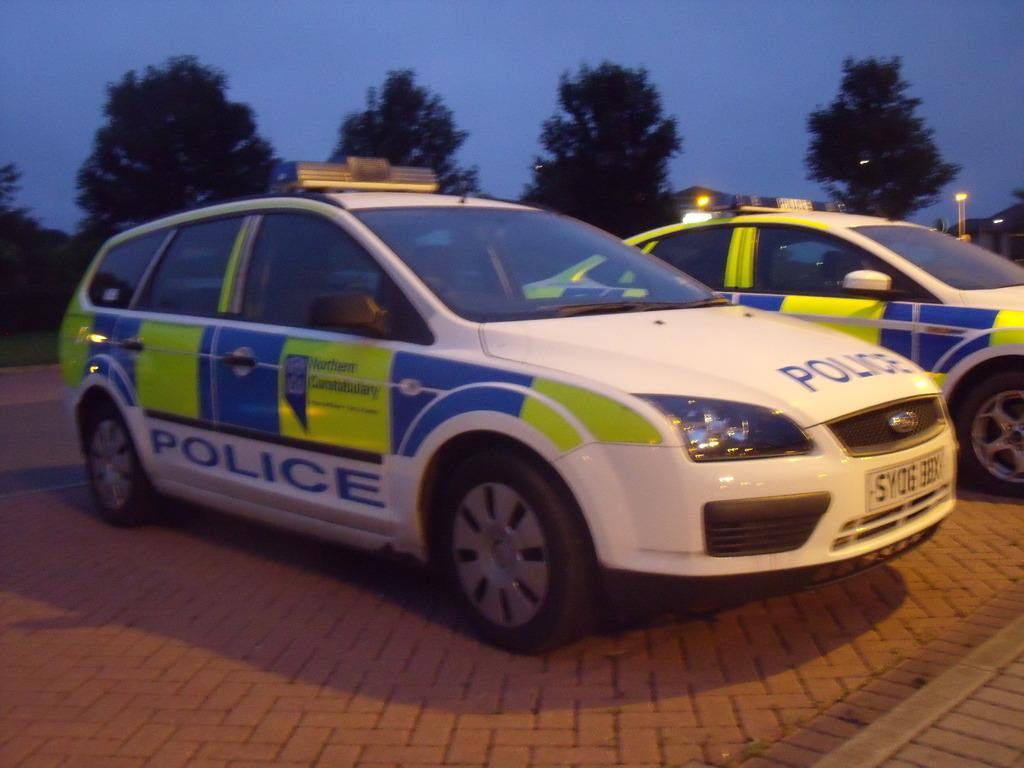Please provide a concise description of this image. In this picture I can see cars. I can see trees in the background. I can see the sky is clear. 